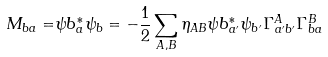<formula> <loc_0><loc_0><loc_500><loc_500>M _ { b a } = & \psi b _ { a } ^ { * } \psi _ { b } = - \frac { 1 } { 2 } \sum _ { A , B } \eta _ { A B } \psi b _ { a ^ { \prime } } ^ { * } \psi _ { b ^ { \prime } } \Gamma ^ { A } _ { a ^ { \prime } b ^ { \prime } } \Gamma ^ { B } _ { b a }</formula> 